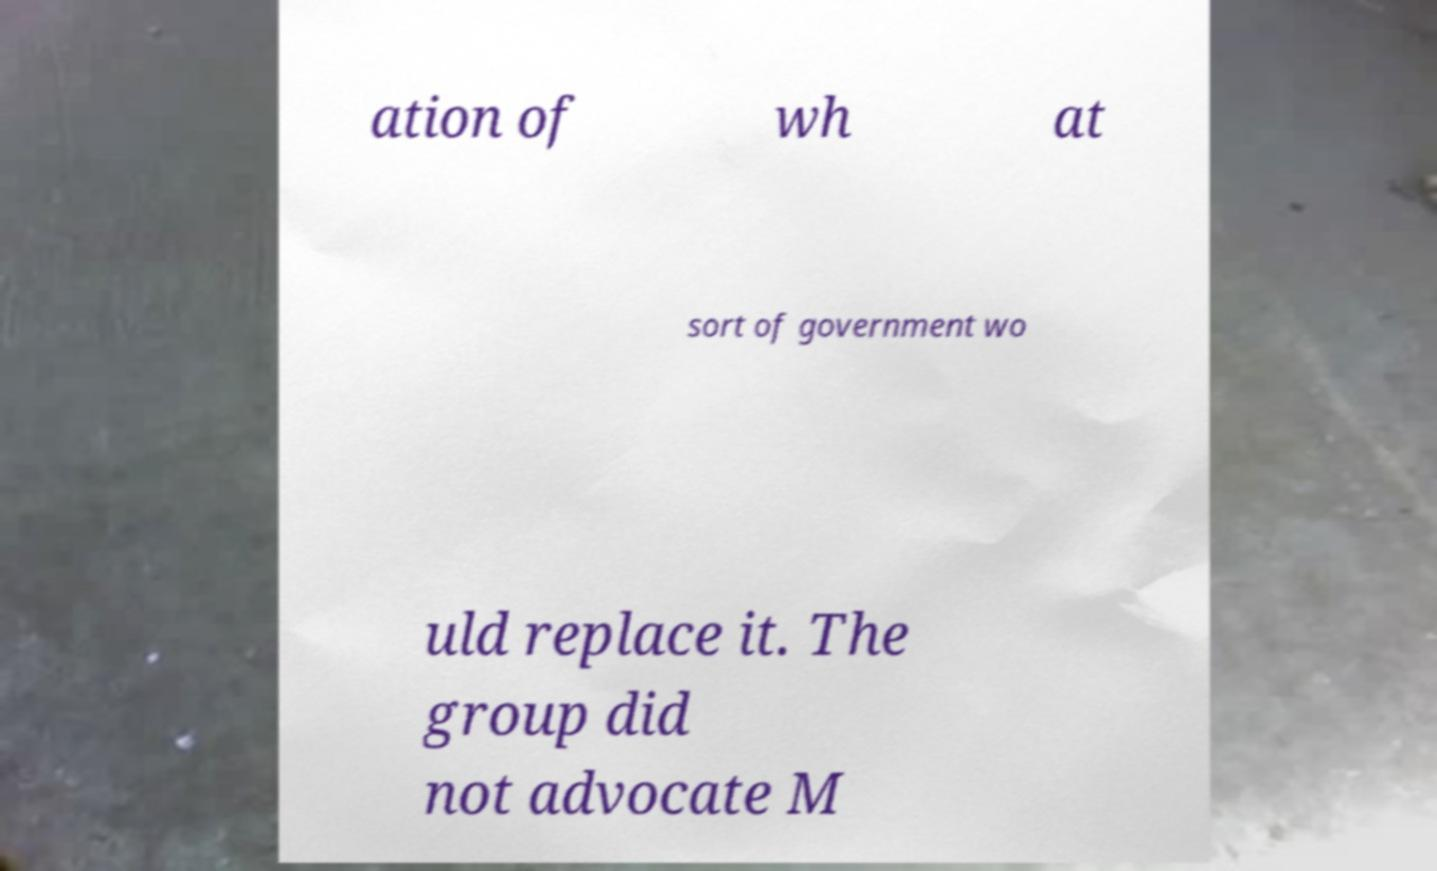What messages or text are displayed in this image? I need them in a readable, typed format. ation of wh at sort of government wo uld replace it. The group did not advocate M 